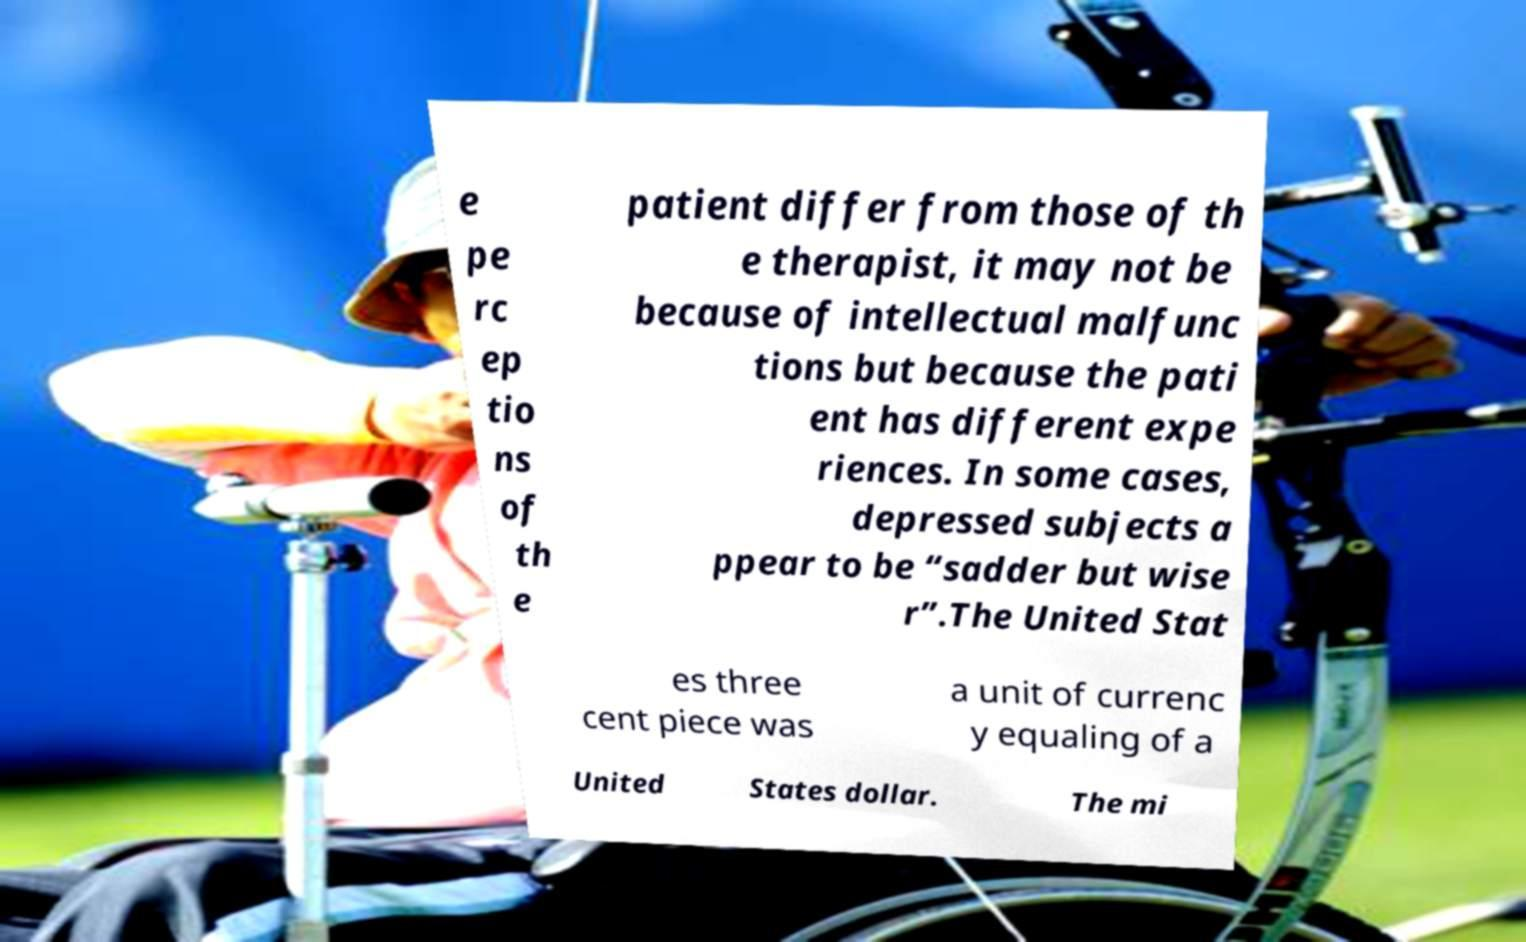I need the written content from this picture converted into text. Can you do that? e pe rc ep tio ns of th e patient differ from those of th e therapist, it may not be because of intellectual malfunc tions but because the pati ent has different expe riences. In some cases, depressed subjects a ppear to be “sadder but wise r”.The United Stat es three cent piece was a unit of currenc y equaling of a United States dollar. The mi 